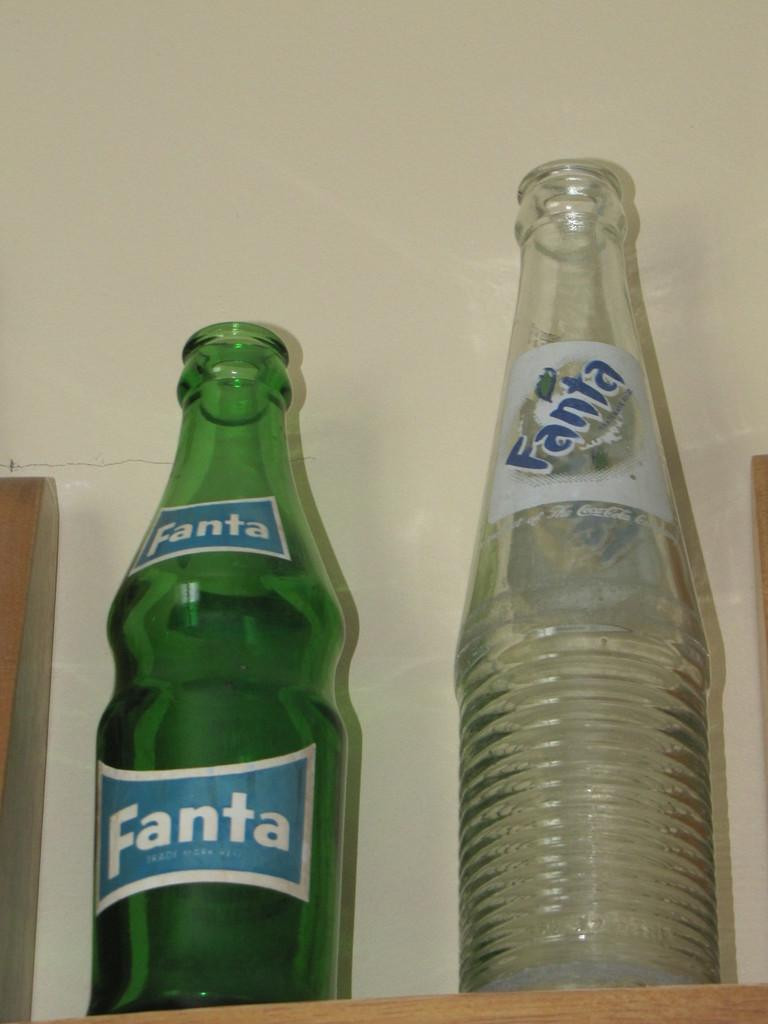<image>
Create a compact narrative representing the image presented. Two Fanta bottles, one green and one clear are next to each other. 